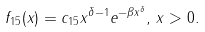<formula> <loc_0><loc_0><loc_500><loc_500>f _ { 1 5 } ( x ) = c _ { 1 5 } x ^ { \delta - 1 } e ^ { - \beta x ^ { \delta } } , \, x > 0 .</formula> 